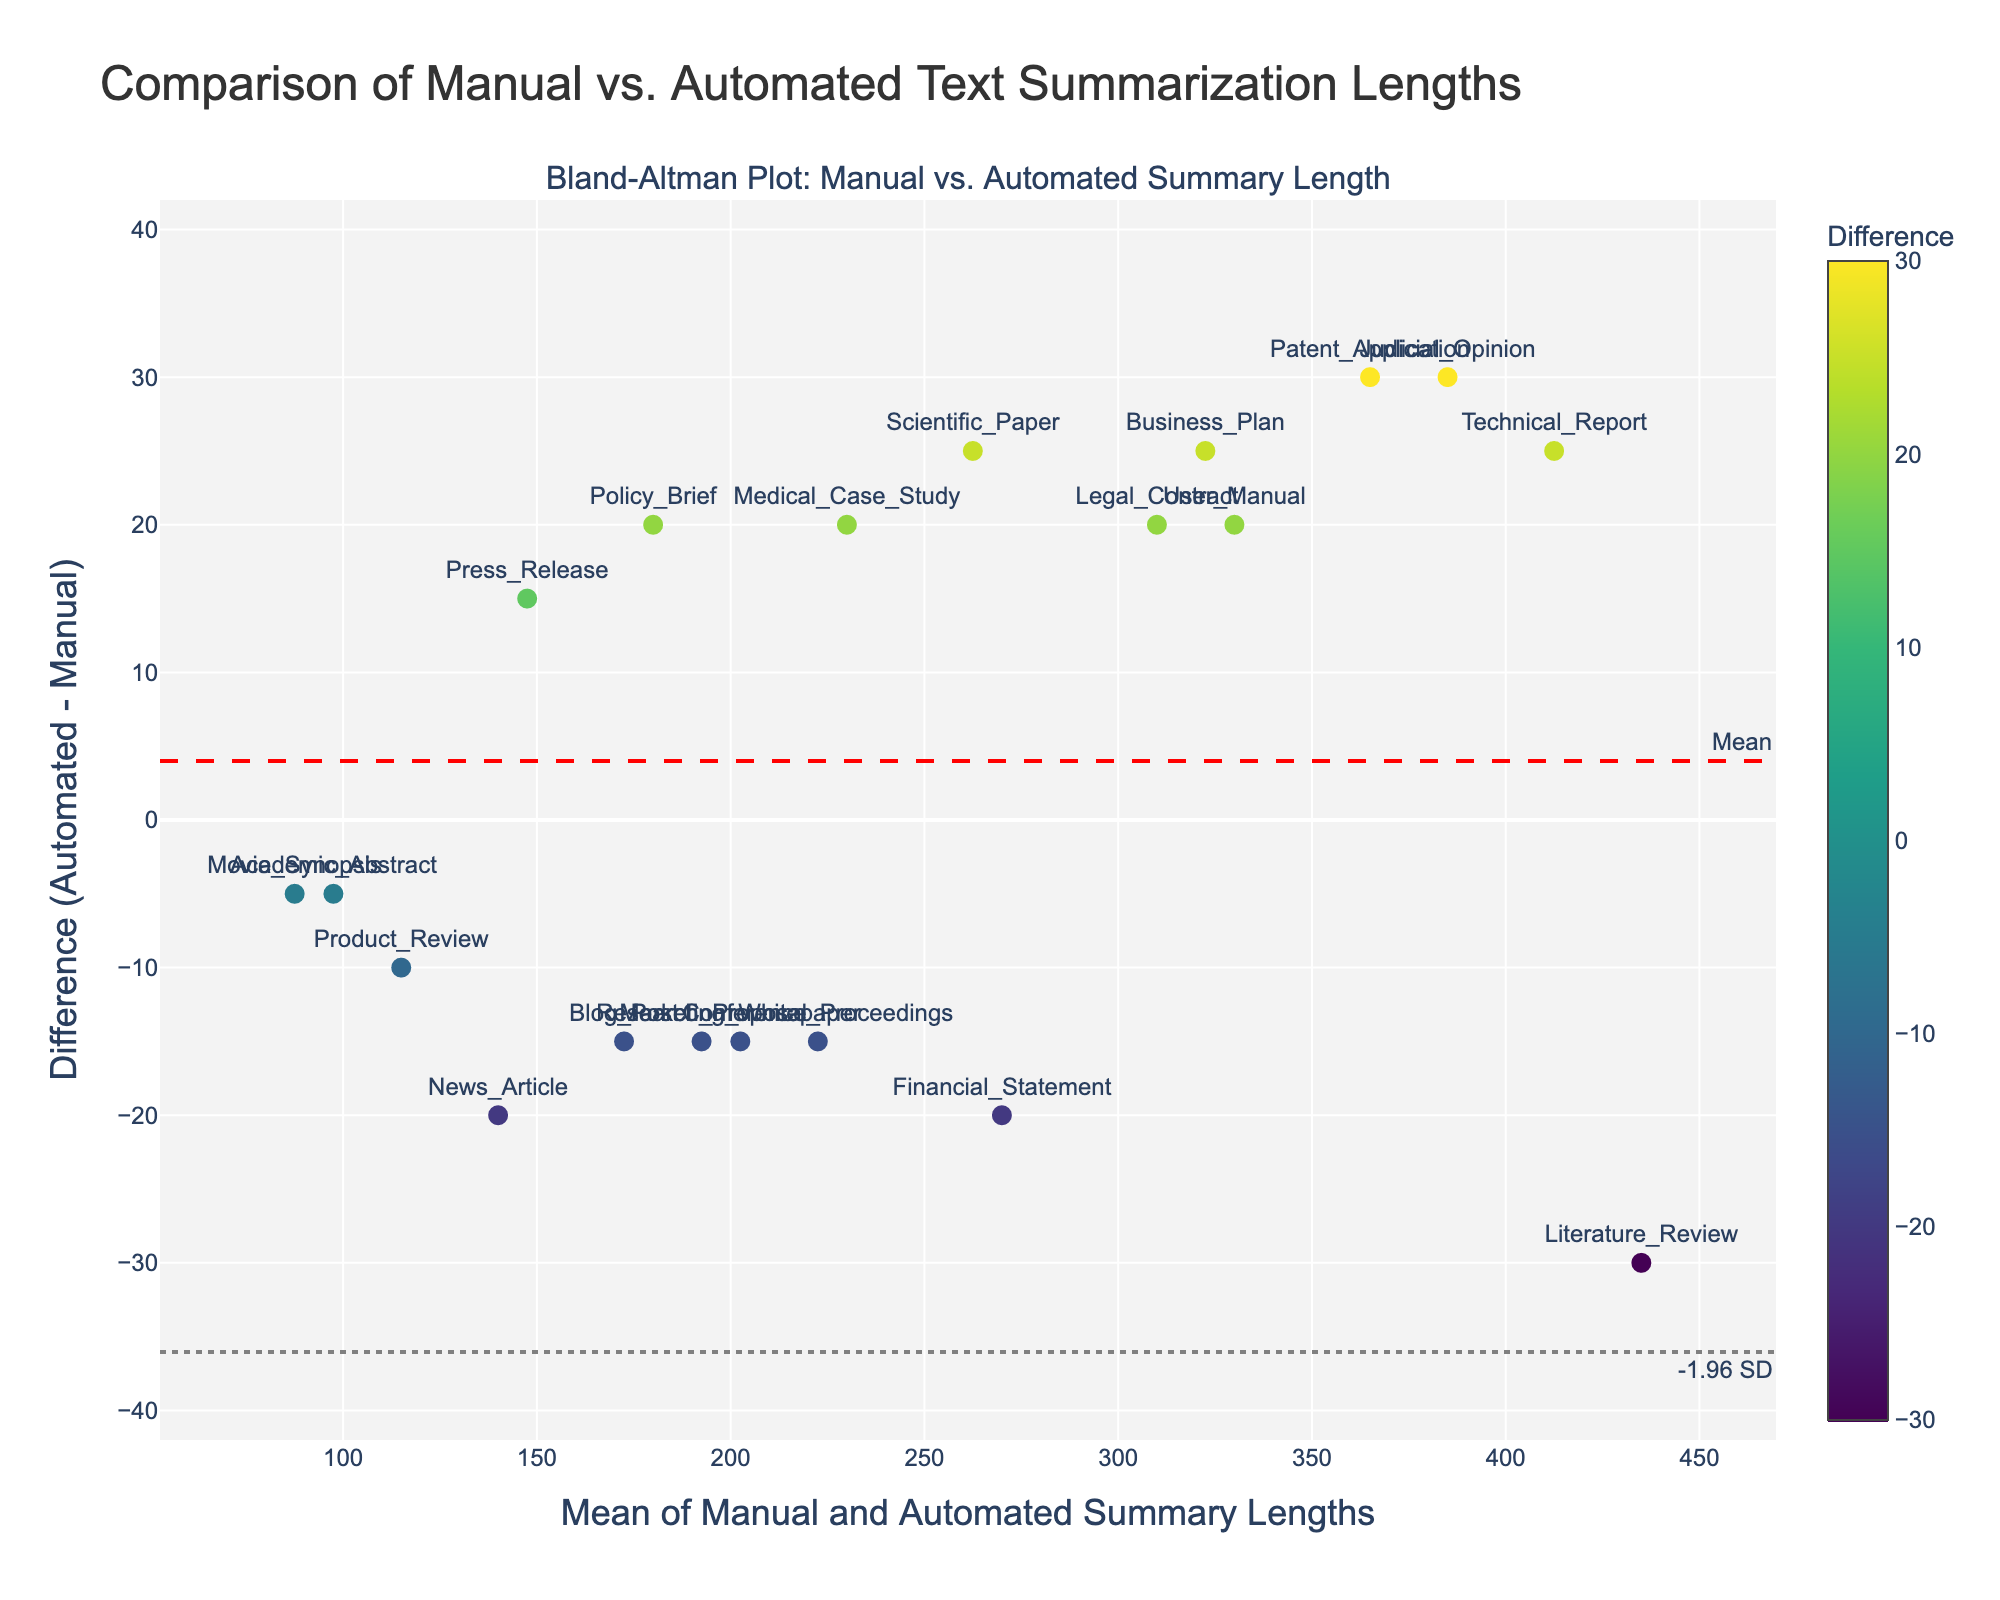What is the title of the plot? The title is found at the top of the plot and typically summarises the visualisation in one line.
Answer: Comparison of Manual vs. Automated Text Summarization Lengths How many document types are displayed in the plot? Each marker and corresponding text label represents a different document type. Count the labels shown on the plot.
Answer: 20 What is the color scale used for the markers? Observing the colors of the markers along with the color bar will indicate the color scale used.
Answer: Viridis Where do the mean difference and limits of agreement lines appear on the y-axis? The mean difference line is dashed in red, and the limits of agreement lines are dotted in gray. Locate these lines on the y-axis to determine their positions. The mean difference line is labeled as "Mean," and the limit lines are labeled as "-1.96 SD" and "+1.96 SD."
Answer: Mean at 11.75, -1.96 SD at -16.56, +1.96 SD at 40.06 Which document type has the largest positive difference between automated and manual summary lengths? Find the marker with the highest position on the y-axis, indicating the greatest difference. Check its label to identify the document type.
Answer: Patent_Application For the document type "Movie_Synopsis," what is the mean of manual and automated summary lengths? Position the marker labeled "Movie_Synopsis" along the x-axis. This value represents the mean of the manual and automated summary lengths.
Answer: 87.5 Which document types have a negative difference between automated and manual summary lengths? Negative differences appear below the baseline of zero on the y-axis. Identify markers below this line and refer to their labels.
Answer: News_Article, Academic_Abstract, Financial_Statement, Product_Review, Conference_Proceedings, Marketing_Whitepaper How does the "Policy_Brief" document type compare to the mean of manual and automated summary lengths? Locate the "Policy_Brief" marker. Check its position relative to the mean difference line. If it's above, automated length is greater, and if below, manual length is higher.
Answer: Above mean Which document type has a difference closest to 0 between manual and automated summary lengths? The document type closest to the y-axis baseline of zero has the smallest difference.
Answer: Academic_Abstract What is the overall trend shown by the differences between manual and automated summaries? Assess the spread and direction of the markers above and below the y-axis baseline and mean line. This indicates the general agreement trend.
Answer: Mostly varied around the mean with some outliers 